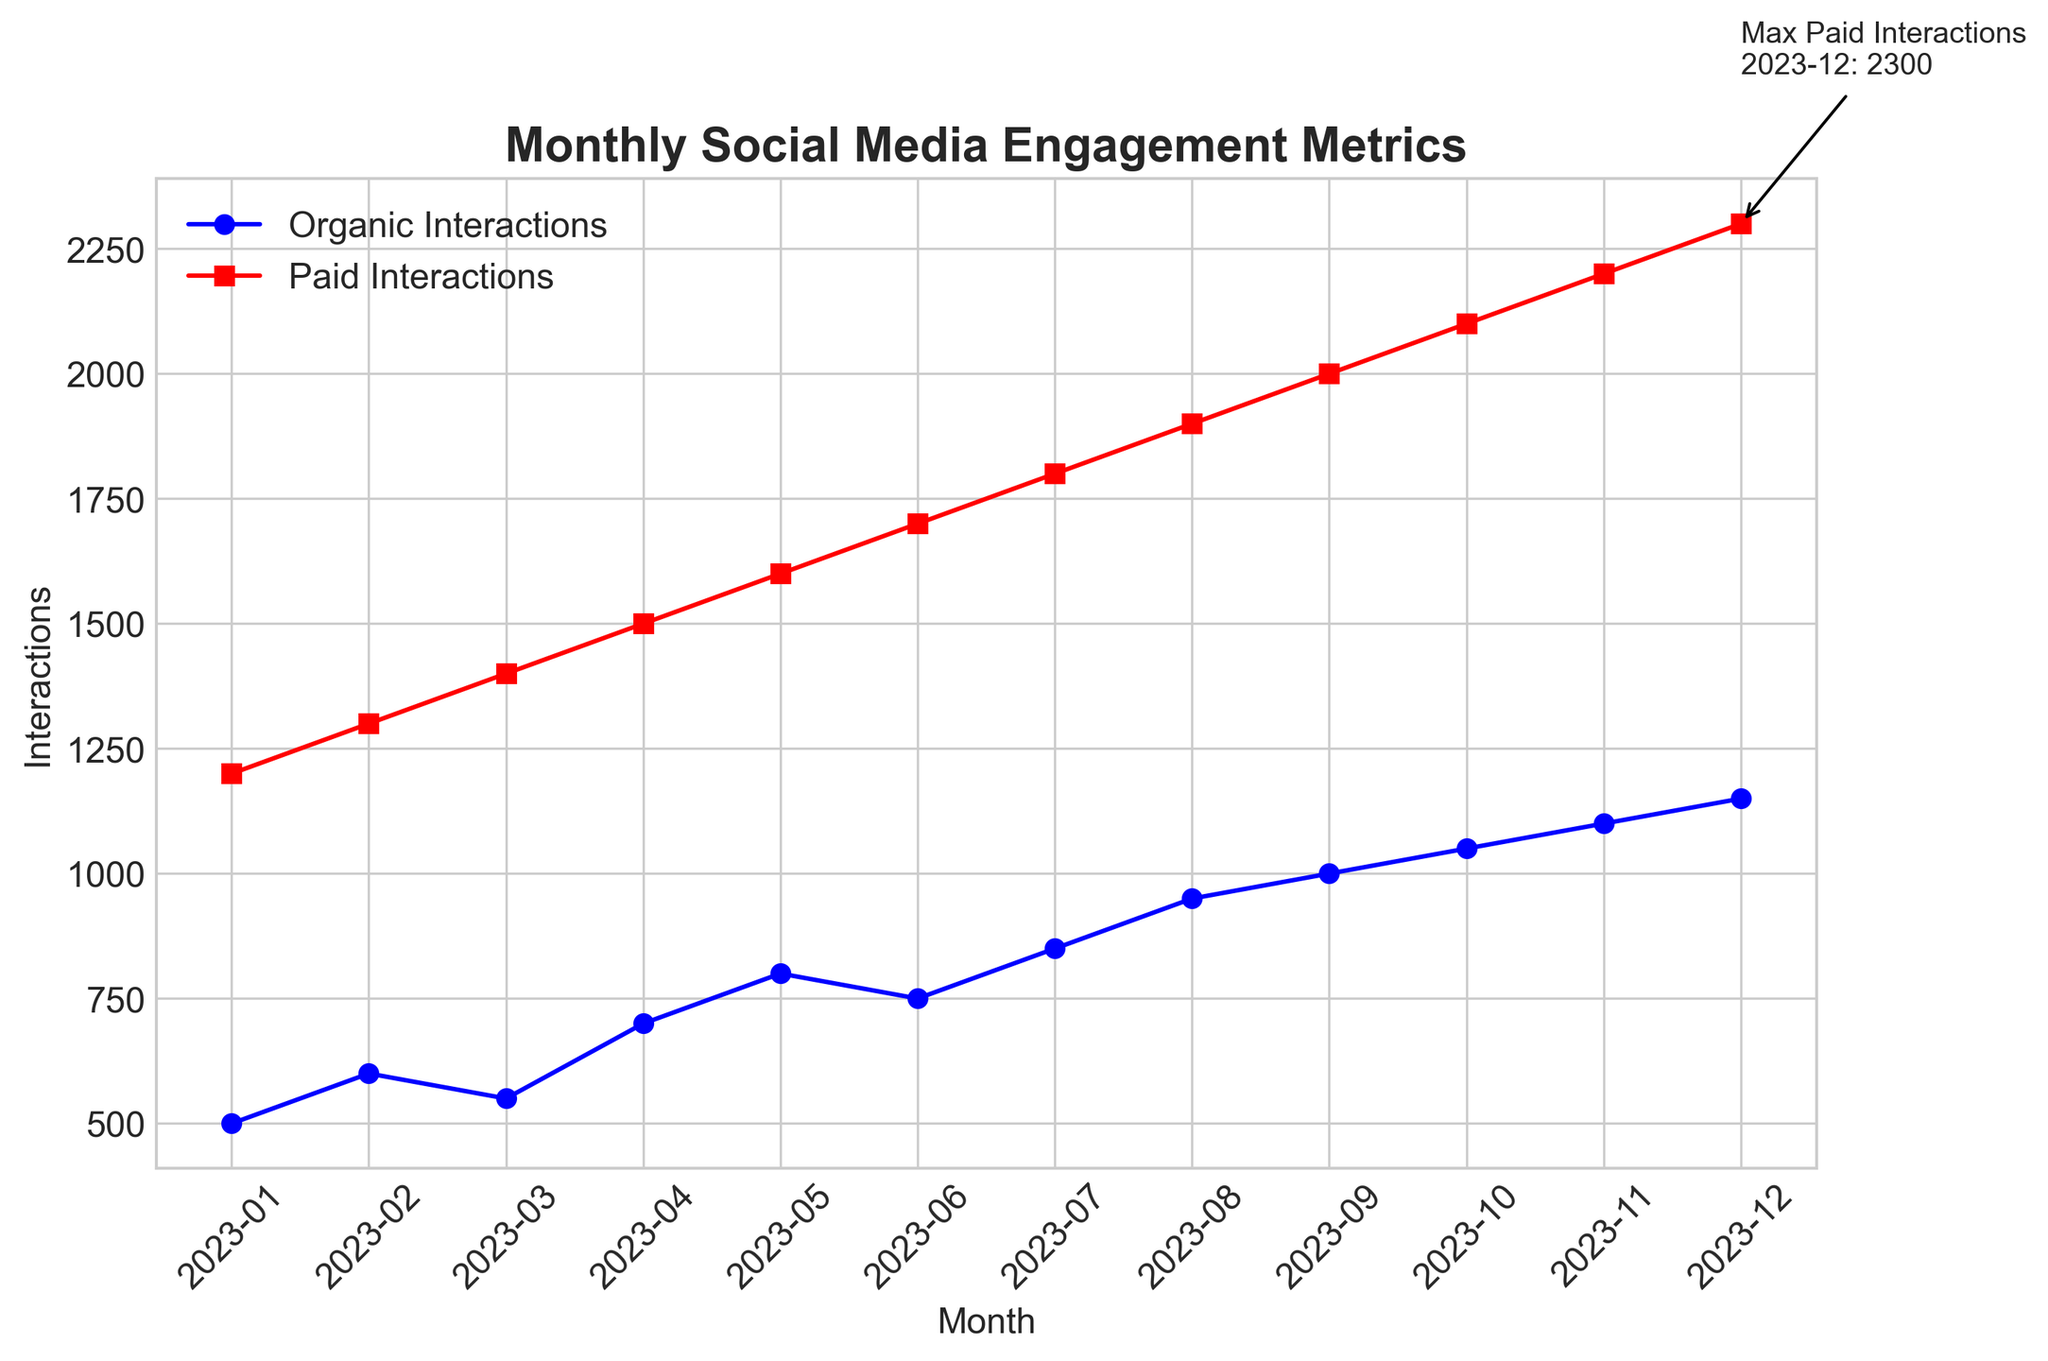What month had the highest number of paid interactions? By looking at the line chart, the highest point for paid interactions is annotated in the figure. The annotation indicates the month "2023-12" with "2300" interactions.
Answer: 2023-12 How do the paid interactions in December compare to the organic interactions in the same month? In December, the paid interactions are indicated by the annotation as 2300. Referring to the same point on the blue line (organic interactions), the value is 1150. The paid interactions are thus 1150 more than organic interactions.
Answer: 1150 more What is the difference between organic and paid interactions in July? For July, the paid interactions are 1800, and the organic interactions are 850. To find the difference, subtract the organic from the paid: 1800 - 850 = 950.
Answer: 950 Which month showed the smallest increase in paid interactions compared to the previous month? We need to calculate the differences for each month. January to February: 100, February to March: 100, March to April: 100, April to May: 100, May to June: 100, June to July: 100, July to August: 100, August to September: 100, September to October: 100, October to November: 100, November to December: 100. All increases are the same, thus there is no smallest increase month.
Answer: No smallest increase What color represents the organic interactions in the chart? Referring to the legend and lines on the plot, the organic interactions are represented by the color blue.
Answer: Blue How much did organic interactions increase from June to July? Organic interactions in June were 750, and in July, they were 850. To find the increase, subtract 750 from 850: 850 - 750 = 100.
Answer: 100 What is the average paid interaction value for the entire year? To find the average, we sum all the monthly values and divide by the number of months: (1200 + 1300 + 1400 + 1500 + 1600 + 1700 + 1800 + 1900 + 2000 + 2100 + 2200 + 2300) / 12 = 20000 / 12 ≈ 1666.67.
Answer: 1666.67 Which month had the largest difference between organic and paid interactions? The differences for each month are calculated: January: 700, February: 700, March: 850, April: 800, May: 800, June: 950, July: 950, August: 950, September: 1000, October: 1050, November: 1100, December: 1150. The largest difference occurs in December.
Answer: December What is the visual evidence indicating the overall trend of paid interactions? Observing the red line representing paid interactions, it is clear that it has an upward slope across the months, indicating an increasing trend throughout the year.
Answer: Increasing trend How many months had organic interactions higher than 900? By looking at the plotted points on the blue line (organic interactions), the months with values higher than 900 are August (950), September (1000), October (1050), November (1100), and December (1150). There are 5 such months.
Answer: 5 